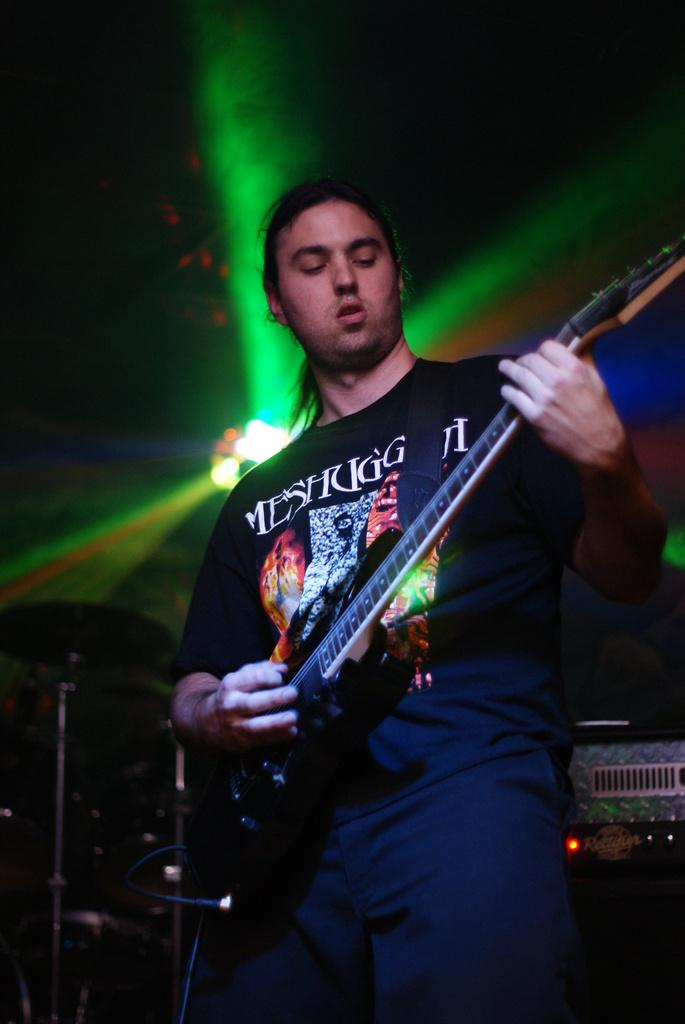What type of event is taking place in the image? It is a music concert. What instrument is the man playing in the image? The man is playing the guitar. What is the man wearing in the image? The man is wearing a black shirt. What can be seen in the background of the image? There are different colors of lights and music instruments in the background. What type of stove is visible in the image? There is no stove present in the image. 